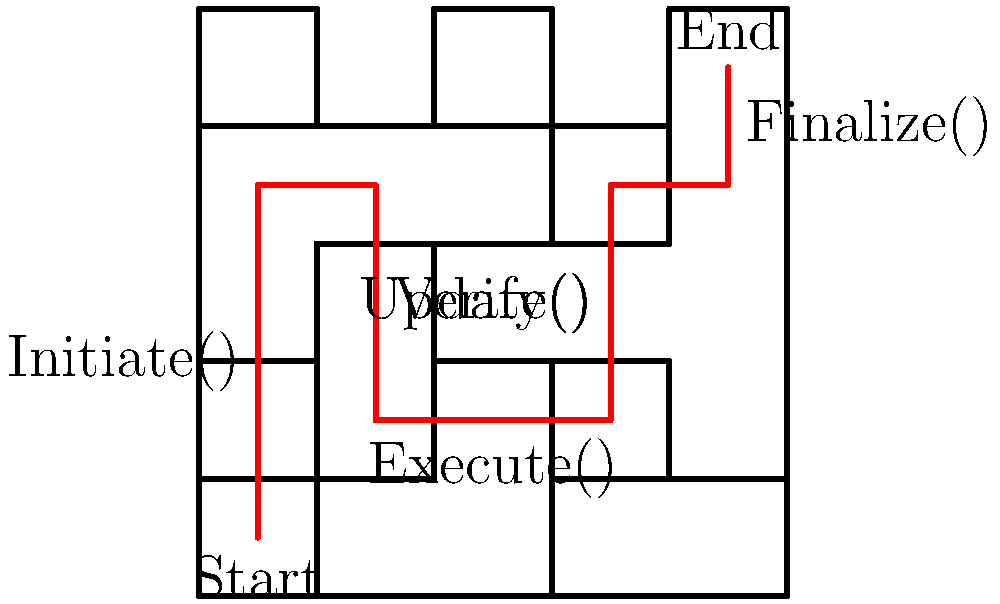In the smart contract maze above, which sequence of functions represents the correct path from Start to End, considering the optimal execution flow for a blockchain-based financial transaction? To solve this maze-like structure representing a complex smart contract, we need to follow the red path from Start to End while identifying the functions encountered along the way. Let's break it down step-by-step:

1. The path begins at "Start" in the bottom-left corner.
2. Moving upward, we encounter the "Initiate()" function. This is typically the first step in a smart contract execution, where the transaction is initiated.
3. Continuing right, we reach the "Verify()" function. This step is crucial in blockchain transactions to ensure the validity of the transaction and the parties involved.
4. Moving downward and then right, we come across the "Execute()" function. This is where the main logic of the smart contract is carried out, such as transferring assets or updating balances.
5. Going upward again, we encounter the "Update()" function. This step likely involves updating the state of the blockchain or the contract after the main execution.
6. Finally, we reach the "Finalize()" function near the "End" point. This function typically concludes the transaction, possibly by emitting events or performing final checks.

The optimal execution flow for a blockchain-based financial transaction would follow this logical sequence: initiate the transaction, verify its validity, execute the main logic, update the state, and finalize the process.
Answer: Initiate() → Verify() → Execute() → Update() → Finalize() 